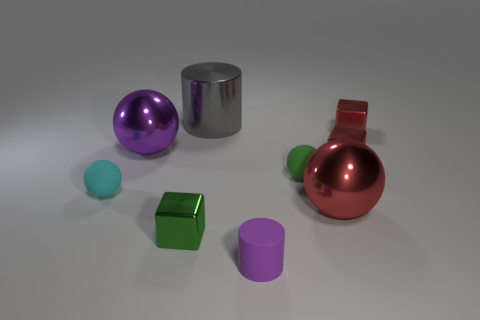Add 1 cyan objects. How many objects exist? 10 Subtract all cubes. How many objects are left? 6 Subtract all tiny shiny blocks. Subtract all green metal cubes. How many objects are left? 5 Add 5 purple cylinders. How many purple cylinders are left? 6 Add 9 large brown cubes. How many large brown cubes exist? 9 Subtract 0 red cylinders. How many objects are left? 9 